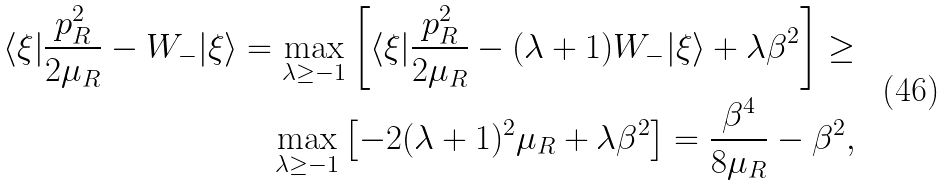<formula> <loc_0><loc_0><loc_500><loc_500>\langle \xi | \frac { { p } _ { R } ^ { 2 } } { 2 \mu _ { R } } - W _ { - } | \xi \rangle = \max _ { \lambda \geq - 1 } \left [ \langle \xi | \frac { { p } _ { R } ^ { 2 } } { 2 \mu _ { R } } - ( \lambda + 1 ) W _ { - } | \xi \rangle + \lambda \beta ^ { 2 } \right ] \geq \\ \max _ { \lambda \geq - 1 } \left [ - 2 ( \lambda + 1 ) ^ { 2 } \mu _ { R } + \lambda \beta ^ { 2 } \right ] = \frac { \beta ^ { 4 } } { 8 \mu _ { R } } - \beta ^ { 2 } ,</formula> 